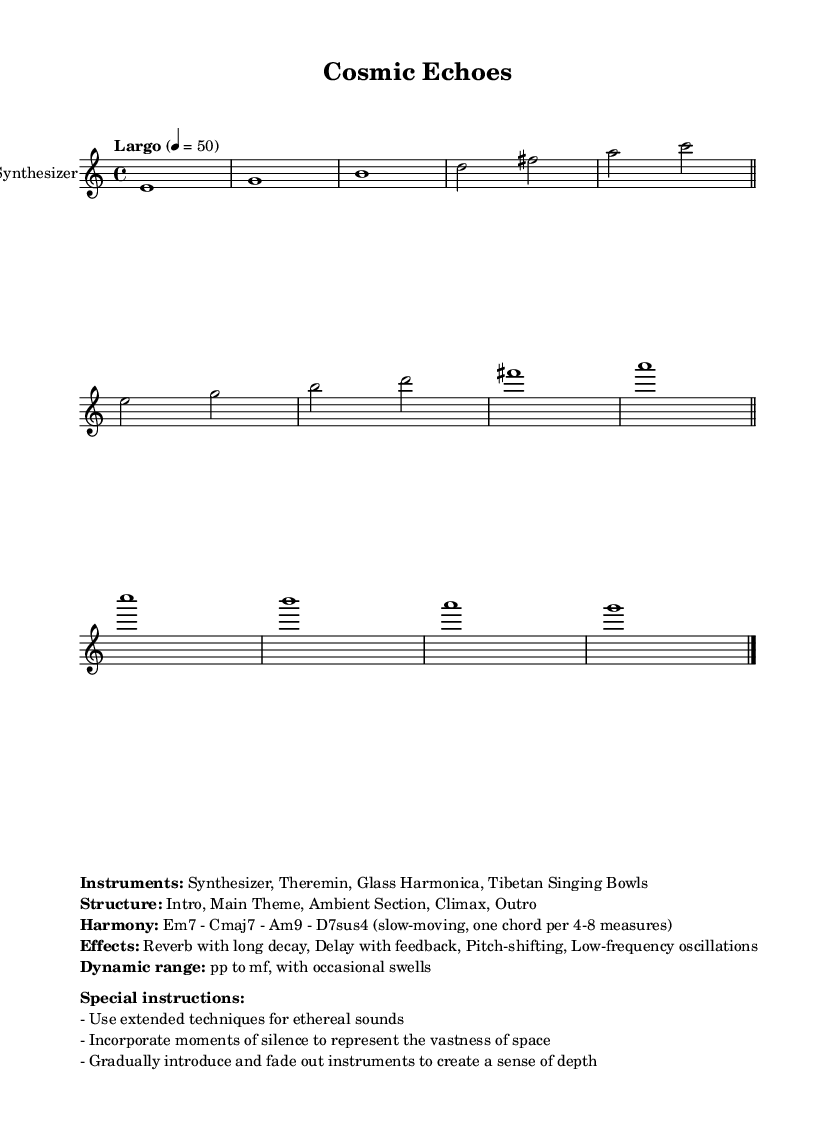What is the time signature of this music? The time signature is 4/4, indicated at the beginning of the score with the notation. This means there are four beats in each measure, and the quarter note gets one beat.
Answer: 4/4 What is the tempo marking given in the score? The tempo marking is "Largo" with a metronome indication of 4 = 50. This indicates a slow tempo, specifically 50 beats per minute.
Answer: Largo, 4 = 50 What instruments are used in this composition? The instruments listed in the markup include a Synthesizer, Theremin, Glass Harmonica, and Tibetan Singing Bowls. This notation is presented in clear, bold text in the markup section.
Answer: Synthesizer, Theremin, Glass Harmonica, Tibetan Singing Bowls How many measures are there in the main melody? The main melody section contains a total of eight measures. This can be counted from the beginning of the synthMelody up to the first bar line of the outro notation.
Answer: 8 What chords are used in the harmony? The harmony utilizes the chords Em7, Cmaj7, Am9, and D7sus4, providing a slow-moving harmonic backdrop for the piece, indicated in the markup section.
Answer: Em7, Cmaj7, Am9, D7sus4 What dynamic range is indicated for this composition? The dynamic range indicated is from piano (pp) to mezzo-forte (mf), suggesting that the piece generally maintains a soft dynamic with occasional swells to a moderately loud dynamic. This information is provided in the markup.
Answer: pp to mf 